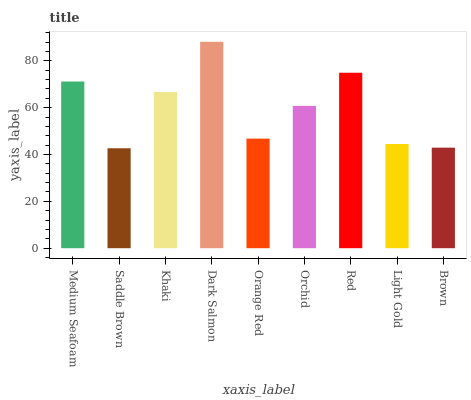Is Saddle Brown the minimum?
Answer yes or no. Yes. Is Dark Salmon the maximum?
Answer yes or no. Yes. Is Khaki the minimum?
Answer yes or no. No. Is Khaki the maximum?
Answer yes or no. No. Is Khaki greater than Saddle Brown?
Answer yes or no. Yes. Is Saddle Brown less than Khaki?
Answer yes or no. Yes. Is Saddle Brown greater than Khaki?
Answer yes or no. No. Is Khaki less than Saddle Brown?
Answer yes or no. No. Is Orchid the high median?
Answer yes or no. Yes. Is Orchid the low median?
Answer yes or no. Yes. Is Red the high median?
Answer yes or no. No. Is Dark Salmon the low median?
Answer yes or no. No. 